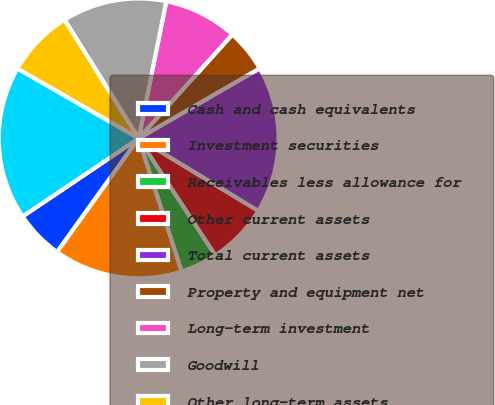Convert chart. <chart><loc_0><loc_0><loc_500><loc_500><pie_chart><fcel>Cash and cash equivalents<fcel>Investment securities<fcel>Receivables less allowance for<fcel>Other current assets<fcel>Total current assets<fcel>Property and equipment net<fcel>Long-term investment<fcel>Goodwill<fcel>Other long-term assets<fcel>Total assets<nl><fcel>5.67%<fcel>14.89%<fcel>4.26%<fcel>7.09%<fcel>17.02%<fcel>4.97%<fcel>8.51%<fcel>12.06%<fcel>7.8%<fcel>17.73%<nl></chart> 